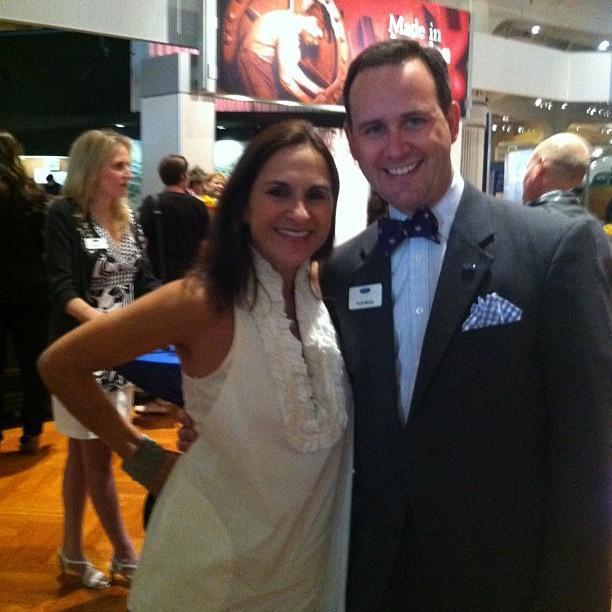At which event do these people pose?
Choose the right answer and clarify with the format: 'Answer: answer
Rationale: rationale.'
Options: Exhibition, mall, office meeting, zoo. Answer: exhibition.
Rationale: Based on their clothes they are not at a zoo or a mall and there is no meeting taking place. 